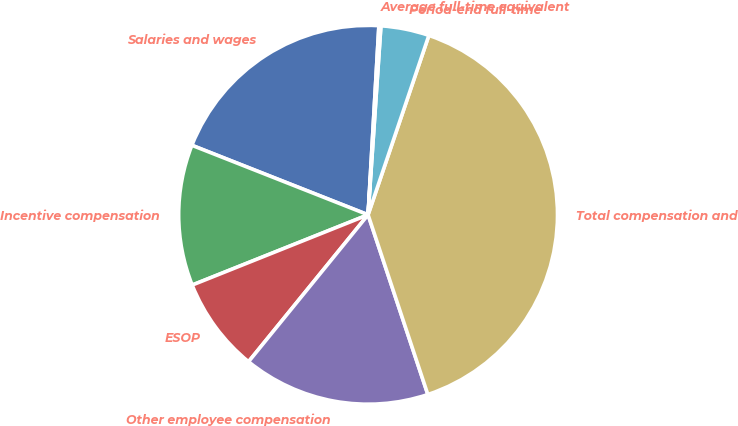Convert chart. <chart><loc_0><loc_0><loc_500><loc_500><pie_chart><fcel>Salaries and wages<fcel>Incentive compensation<fcel>ESOP<fcel>Other employee compensation<fcel>Total compensation and<fcel>Period-end full-time<fcel>Average full-time equivalent<nl><fcel>19.93%<fcel>12.03%<fcel>8.08%<fcel>15.98%<fcel>39.69%<fcel>4.12%<fcel>0.17%<nl></chart> 